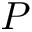Convert formula to latex. <formula><loc_0><loc_0><loc_500><loc_500>P</formula> 